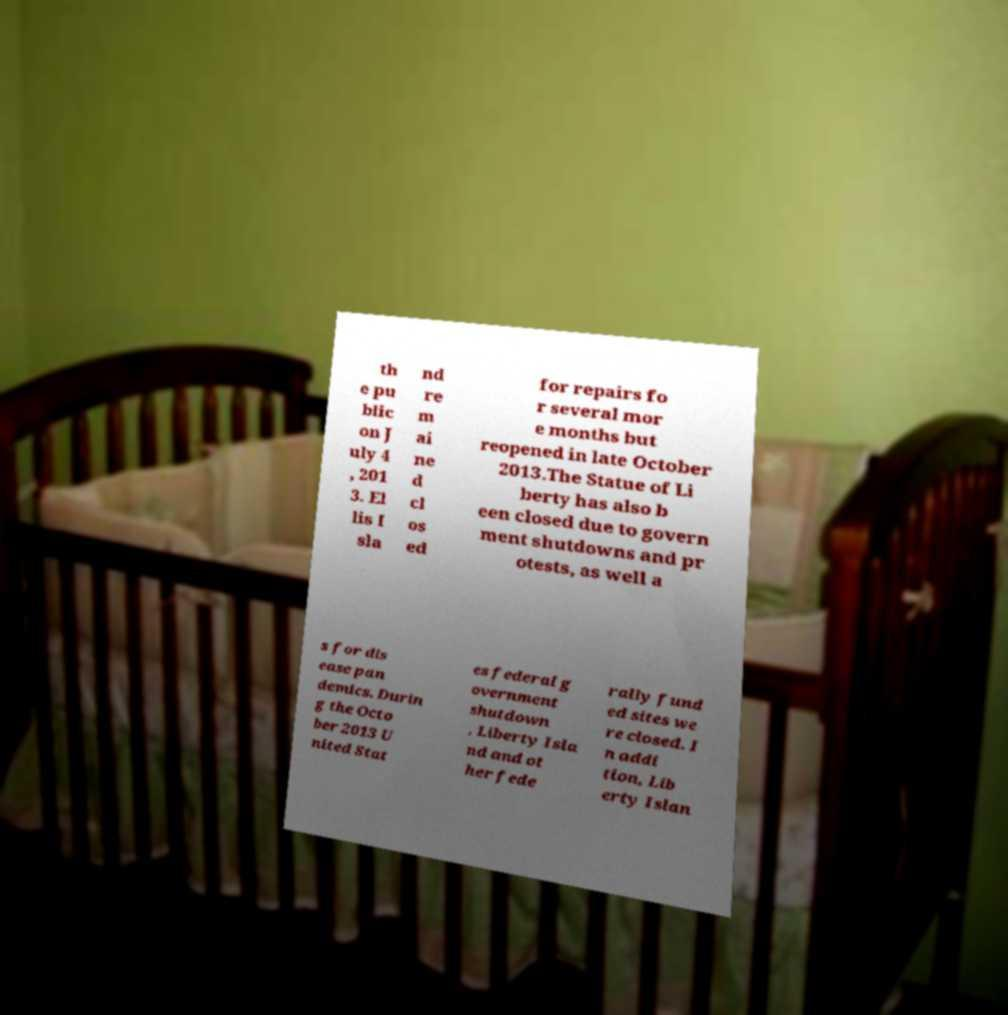Can you accurately transcribe the text from the provided image for me? th e pu blic on J uly 4 , 201 3. El lis I sla nd re m ai ne d cl os ed for repairs fo r several mor e months but reopened in late October 2013.The Statue of Li berty has also b een closed due to govern ment shutdowns and pr otests, as well a s for dis ease pan demics. Durin g the Octo ber 2013 U nited Stat es federal g overnment shutdown , Liberty Isla nd and ot her fede rally fund ed sites we re closed. I n addi tion, Lib erty Islan 